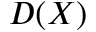<formula> <loc_0><loc_0><loc_500><loc_500>D ( X )</formula> 